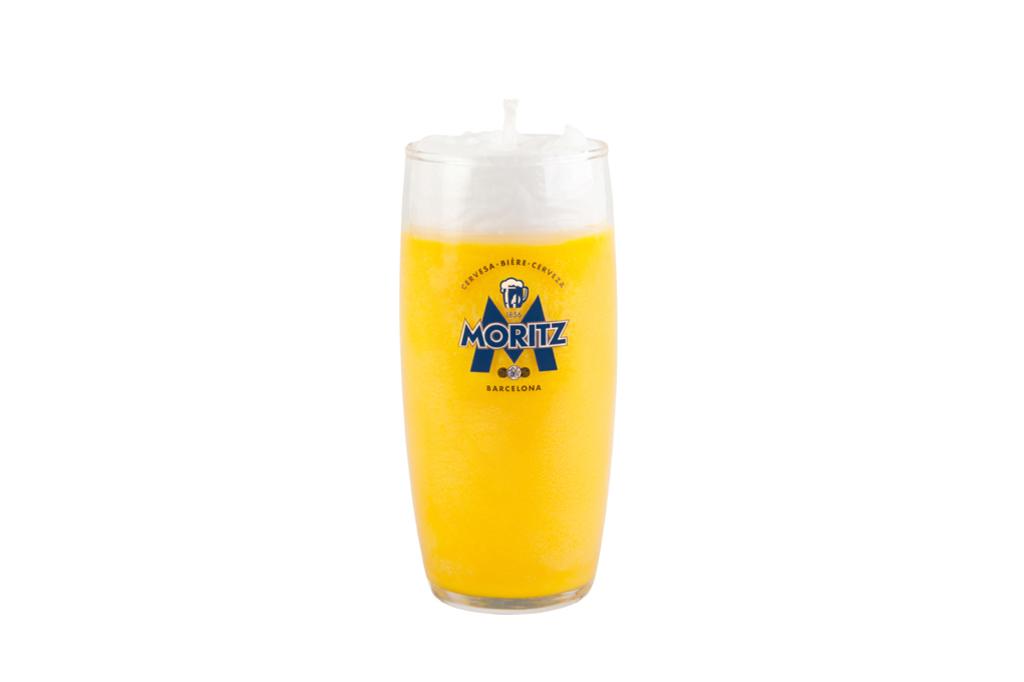What brand of beer is this?
Offer a terse response. Moritz. Which city is this drink made from?
Your answer should be compact. Barcelona. 